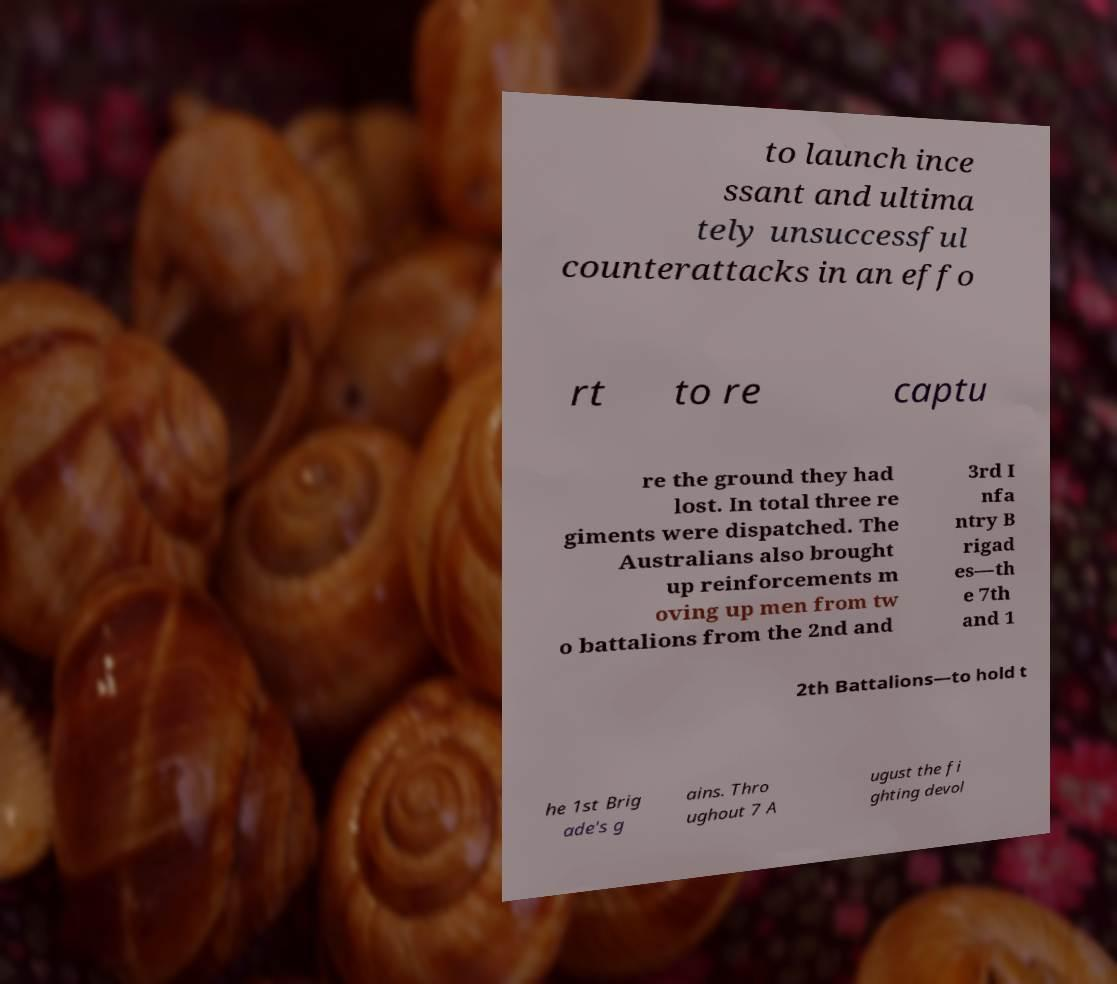What messages or text are displayed in this image? I need them in a readable, typed format. to launch ince ssant and ultima tely unsuccessful counterattacks in an effo rt to re captu re the ground they had lost. In total three re giments were dispatched. The Australians also brought up reinforcements m oving up men from tw o battalions from the 2nd and 3rd I nfa ntry B rigad es—th e 7th and 1 2th Battalions—to hold t he 1st Brig ade's g ains. Thro ughout 7 A ugust the fi ghting devol 